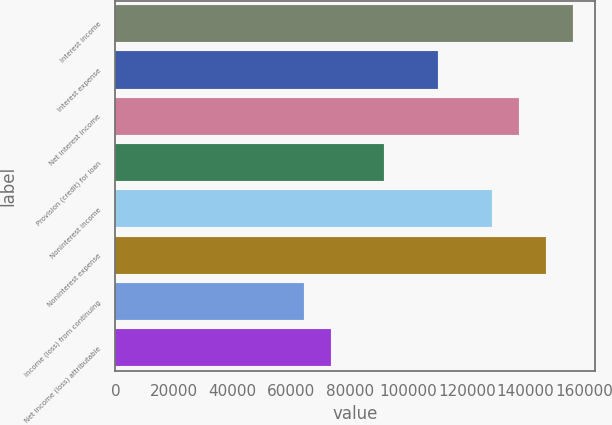Convert chart. <chart><loc_0><loc_0><loc_500><loc_500><bar_chart><fcel>Interest income<fcel>Interest expense<fcel>Net interest income<fcel>Provision (credit) for loan<fcel>Noninterest income<fcel>Noninterest expense<fcel>Income (loss) from continuing<fcel>Net income (loss) attributable<nl><fcel>156133<fcel>110212<fcel>137765<fcel>91843<fcel>128580<fcel>146949<fcel>64290.1<fcel>73474.4<nl></chart> 